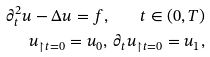Convert formula to latex. <formula><loc_0><loc_0><loc_500><loc_500>\partial _ { t } ^ { 2 } u - \Delta u = f , \quad t \in ( 0 , T ) \\ u _ { \restriction t = 0 } = u _ { 0 } , \, \partial _ { t } u _ { \restriction t = 0 } = u _ { 1 } ,</formula> 